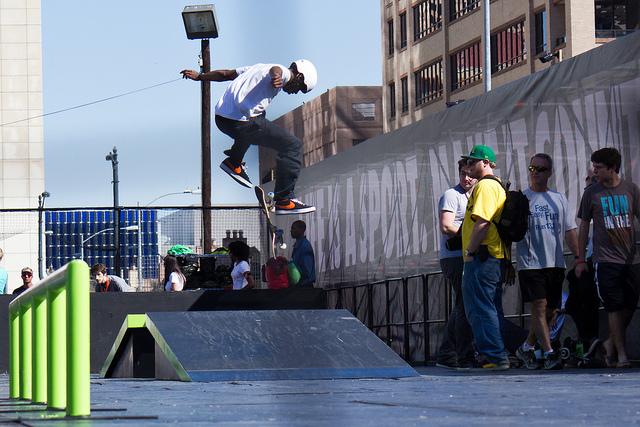What is cast?
Quick response, please. Skateboarder. How many people attended the event?
Answer briefly. 10. What color hat is the guy in yellow wearing?
Short answer required. Green. What activity are they watching?
Write a very short answer. Skateboarding. 